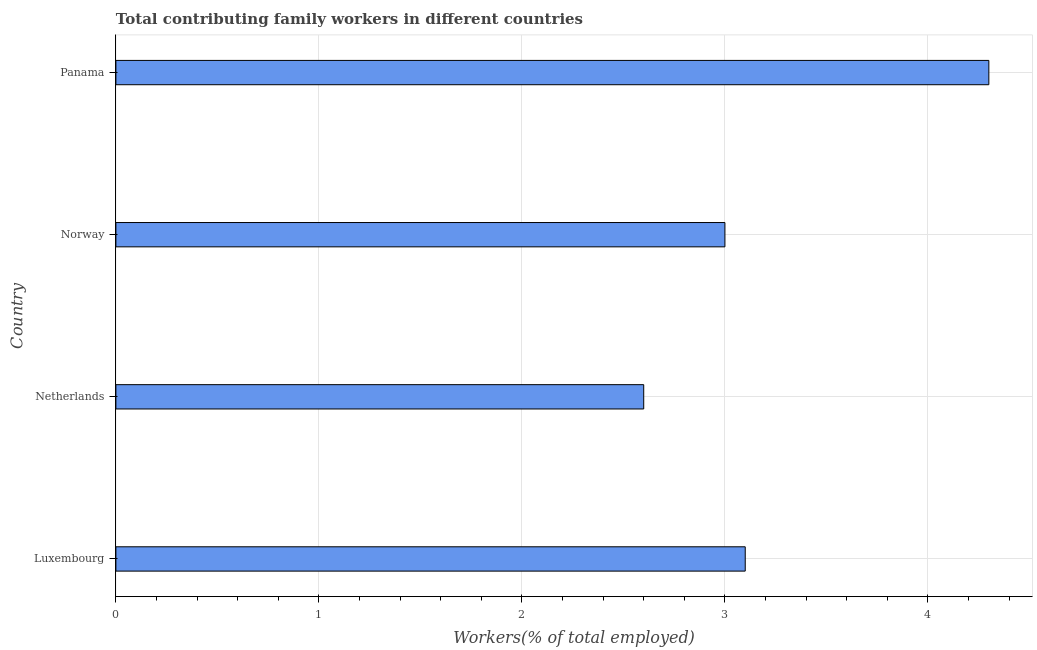Does the graph contain any zero values?
Your answer should be very brief. No. Does the graph contain grids?
Make the answer very short. Yes. What is the title of the graph?
Your answer should be compact. Total contributing family workers in different countries. What is the label or title of the X-axis?
Give a very brief answer. Workers(% of total employed). What is the contributing family workers in Norway?
Ensure brevity in your answer.  3. Across all countries, what is the maximum contributing family workers?
Offer a terse response. 4.3. Across all countries, what is the minimum contributing family workers?
Your answer should be compact. 2.6. In which country was the contributing family workers maximum?
Your answer should be compact. Panama. What is the sum of the contributing family workers?
Ensure brevity in your answer.  13. What is the difference between the contributing family workers in Netherlands and Norway?
Ensure brevity in your answer.  -0.4. What is the median contributing family workers?
Offer a terse response. 3.05. What is the ratio of the contributing family workers in Norway to that in Panama?
Ensure brevity in your answer.  0.7. Is the contributing family workers in Luxembourg less than that in Netherlands?
Give a very brief answer. No. Is the difference between the contributing family workers in Luxembourg and Netherlands greater than the difference between any two countries?
Ensure brevity in your answer.  No. What is the difference between the highest and the second highest contributing family workers?
Make the answer very short. 1.2. In how many countries, is the contributing family workers greater than the average contributing family workers taken over all countries?
Give a very brief answer. 1. How many bars are there?
Ensure brevity in your answer.  4. How many countries are there in the graph?
Give a very brief answer. 4. Are the values on the major ticks of X-axis written in scientific E-notation?
Provide a short and direct response. No. What is the Workers(% of total employed) in Luxembourg?
Your answer should be compact. 3.1. What is the Workers(% of total employed) of Netherlands?
Your answer should be compact. 2.6. What is the Workers(% of total employed) in Panama?
Offer a very short reply. 4.3. What is the difference between the Workers(% of total employed) in Luxembourg and Panama?
Provide a short and direct response. -1.2. What is the difference between the Workers(% of total employed) in Netherlands and Panama?
Give a very brief answer. -1.7. What is the ratio of the Workers(% of total employed) in Luxembourg to that in Netherlands?
Your answer should be compact. 1.19. What is the ratio of the Workers(% of total employed) in Luxembourg to that in Norway?
Provide a short and direct response. 1.03. What is the ratio of the Workers(% of total employed) in Luxembourg to that in Panama?
Keep it short and to the point. 0.72. What is the ratio of the Workers(% of total employed) in Netherlands to that in Norway?
Give a very brief answer. 0.87. What is the ratio of the Workers(% of total employed) in Netherlands to that in Panama?
Your response must be concise. 0.6. What is the ratio of the Workers(% of total employed) in Norway to that in Panama?
Your response must be concise. 0.7. 